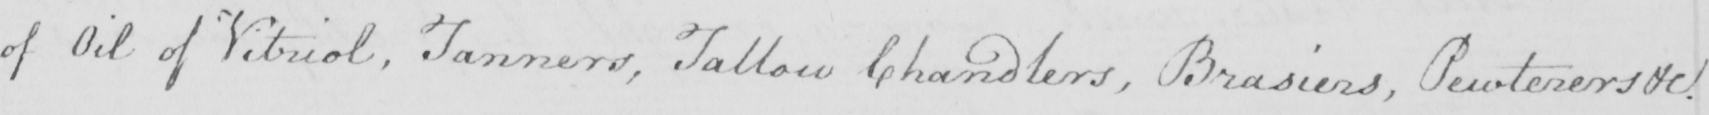Please transcribe the handwritten text in this image. of Oil of Vitriol, Tanners, Tallow Chandlers, Brasiers, Pewterers &c. 